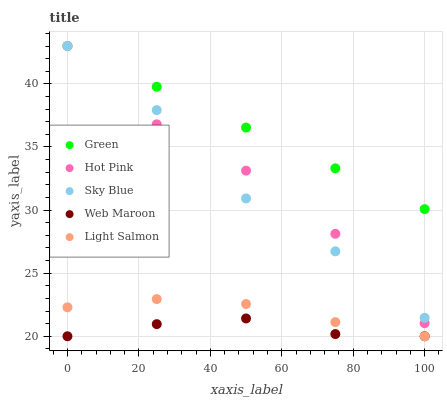Does Web Maroon have the minimum area under the curve?
Answer yes or no. Yes. Does Green have the maximum area under the curve?
Answer yes or no. Yes. Does Light Salmon have the minimum area under the curve?
Answer yes or no. No. Does Light Salmon have the maximum area under the curve?
Answer yes or no. No. Is Green the smoothest?
Answer yes or no. Yes. Is Hot Pink the roughest?
Answer yes or no. Yes. Is Light Salmon the smoothest?
Answer yes or no. No. Is Light Salmon the roughest?
Answer yes or no. No. Does Light Salmon have the lowest value?
Answer yes or no. Yes. Does Hot Pink have the lowest value?
Answer yes or no. No. Does Green have the highest value?
Answer yes or no. Yes. Does Light Salmon have the highest value?
Answer yes or no. No. Is Web Maroon less than Green?
Answer yes or no. Yes. Is Hot Pink greater than Light Salmon?
Answer yes or no. Yes. Does Hot Pink intersect Green?
Answer yes or no. Yes. Is Hot Pink less than Green?
Answer yes or no. No. Is Hot Pink greater than Green?
Answer yes or no. No. Does Web Maroon intersect Green?
Answer yes or no. No. 